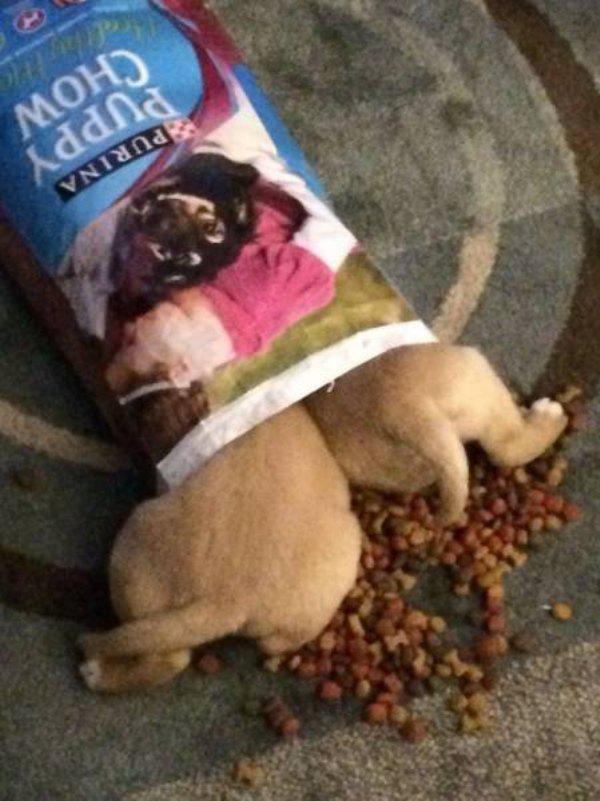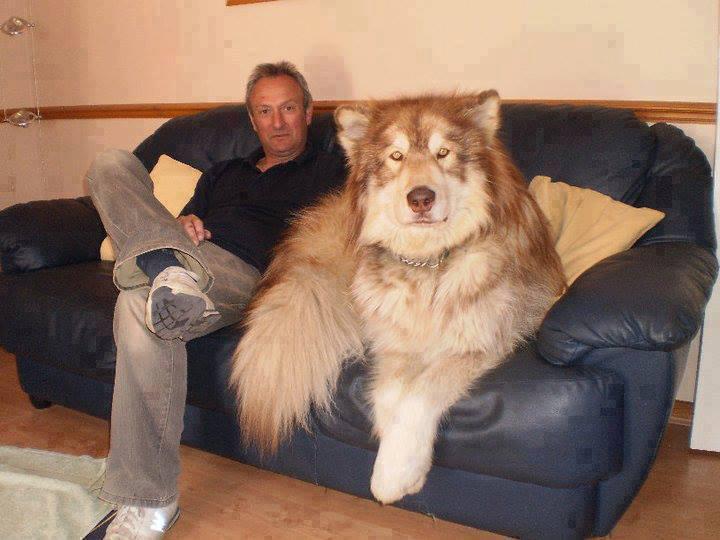The first image is the image on the left, the second image is the image on the right. Analyze the images presented: Is the assertion "There is a human in the image on the right." valid? Answer yes or no. Yes. 